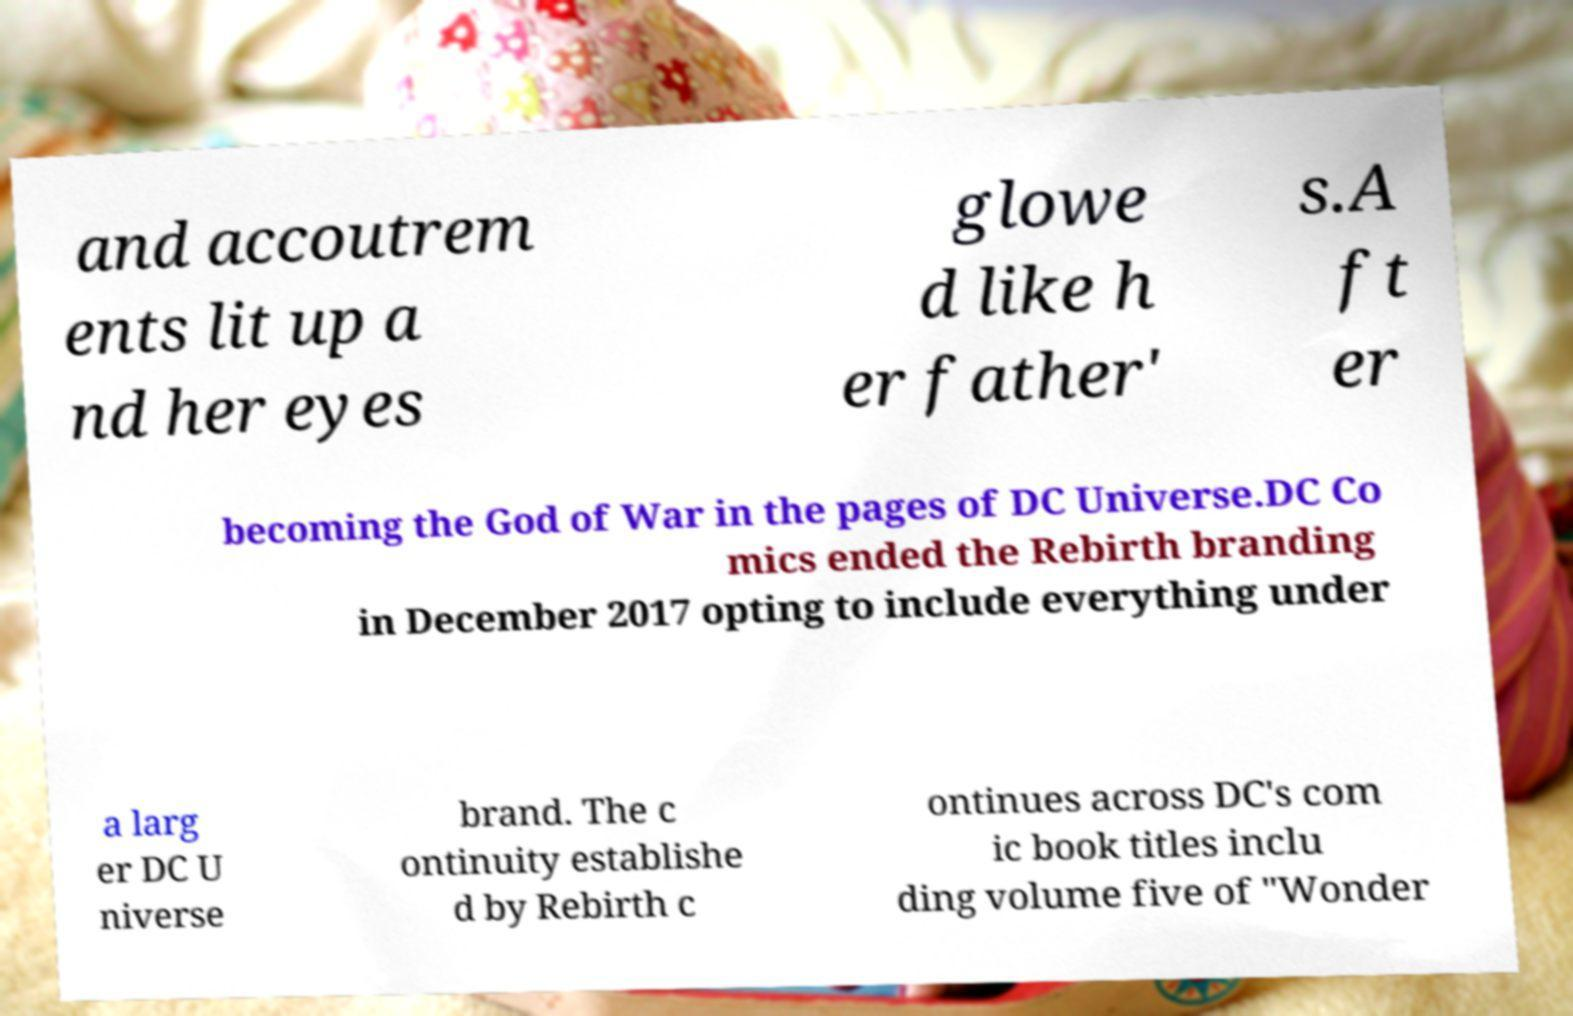There's text embedded in this image that I need extracted. Can you transcribe it verbatim? and accoutrem ents lit up a nd her eyes glowe d like h er father' s.A ft er becoming the God of War in the pages of DC Universe.DC Co mics ended the Rebirth branding in December 2017 opting to include everything under a larg er DC U niverse brand. The c ontinuity establishe d by Rebirth c ontinues across DC's com ic book titles inclu ding volume five of "Wonder 